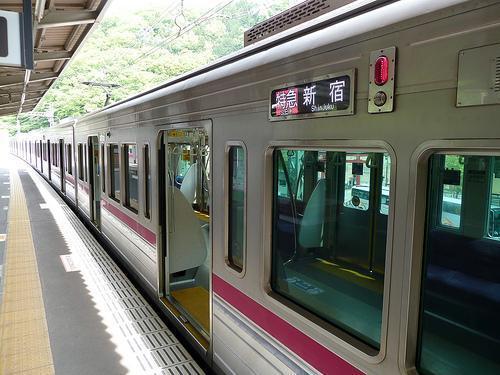How many trains are shown?
Give a very brief answer. 1. 